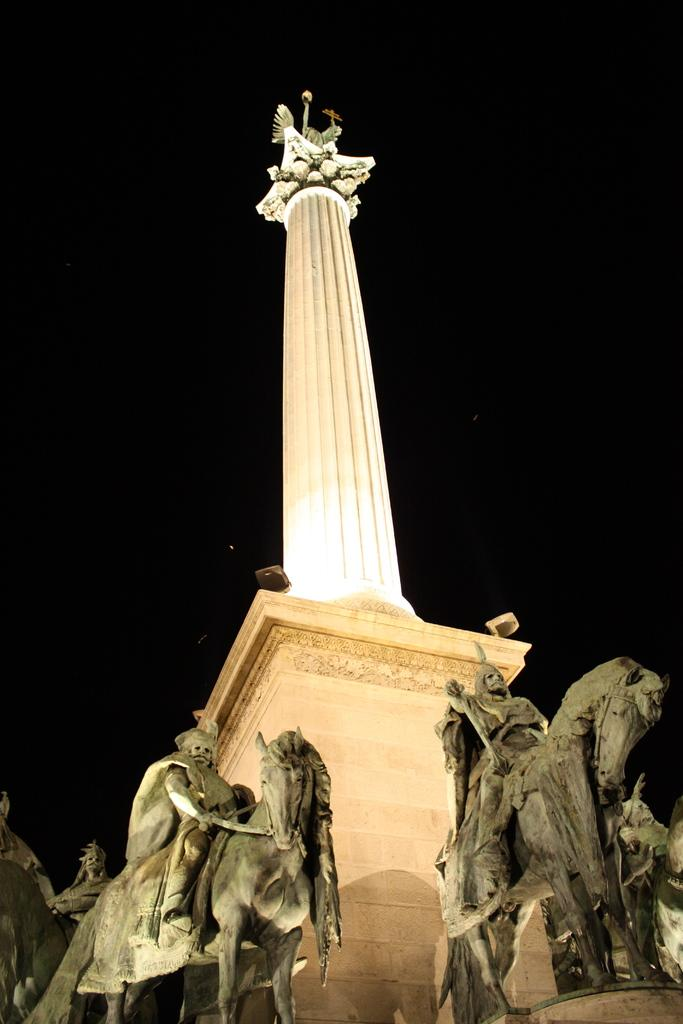What is the main subject of the image? The main subject of the image is a statue on a pillar. Can you describe the background of the image? The background of the image is dark. How many frogs are sitting on the statue in the image? There are no frogs present in the image. What type of plants can be seen growing around the statue in the image? There are no plants visible in the image; the focus is on the statue and the dark background. 